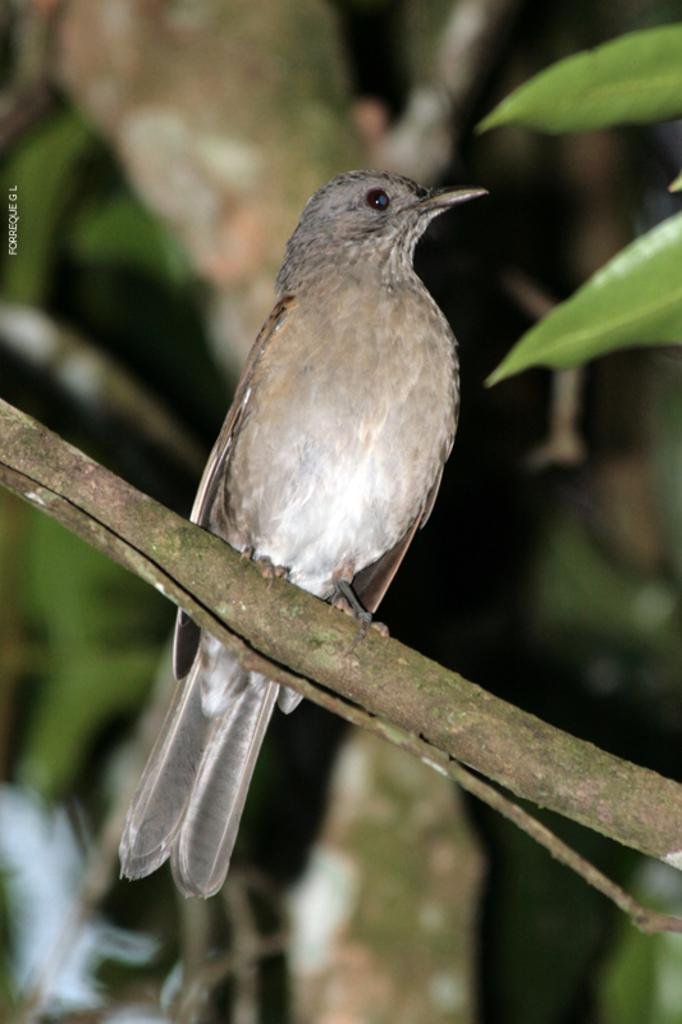What type of animal can be seen in the image? There is a bird in the image. Where is the bird located? The bird is sitting on a stem. What can be seen in the background of the image? There is a tree in the background of the image. What color is the bird's lip in the image? Birds do not have lips, so this detail cannot be observed in the image. 